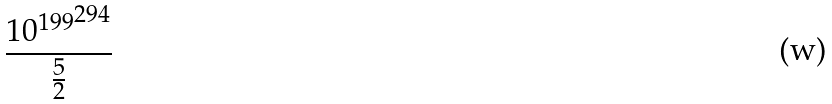<formula> <loc_0><loc_0><loc_500><loc_500>\frac { { 1 0 ^ { 1 9 9 } } ^ { 2 9 4 } } { \frac { 5 } { 2 } }</formula> 